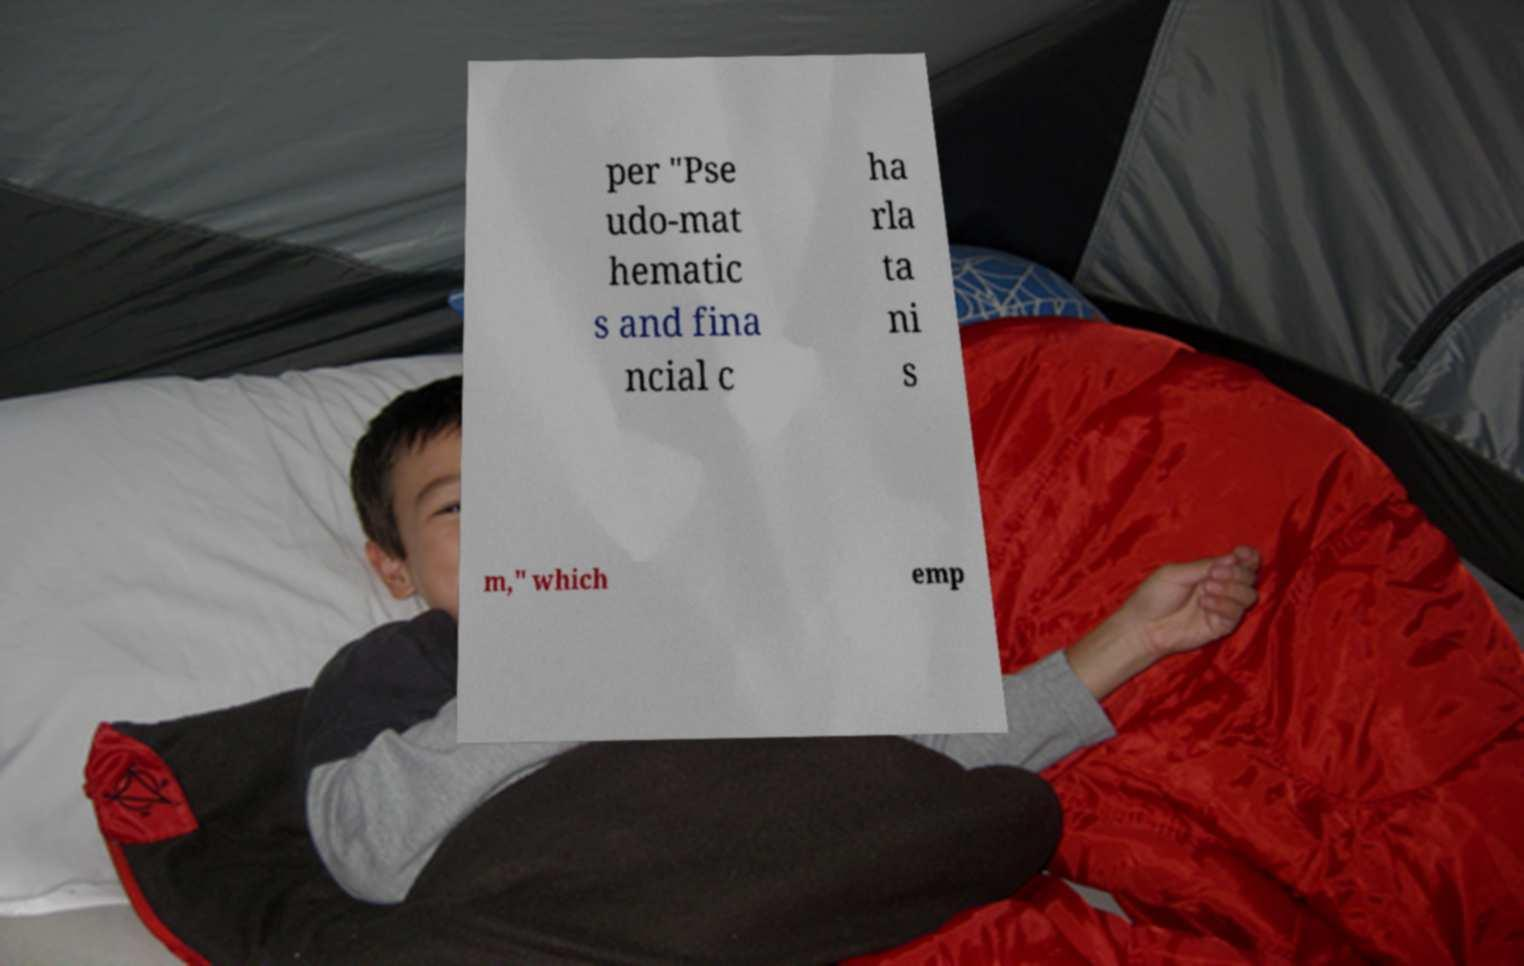What messages or text are displayed in this image? I need them in a readable, typed format. per "Pse udo-mat hematic s and fina ncial c ha rla ta ni s m," which emp 